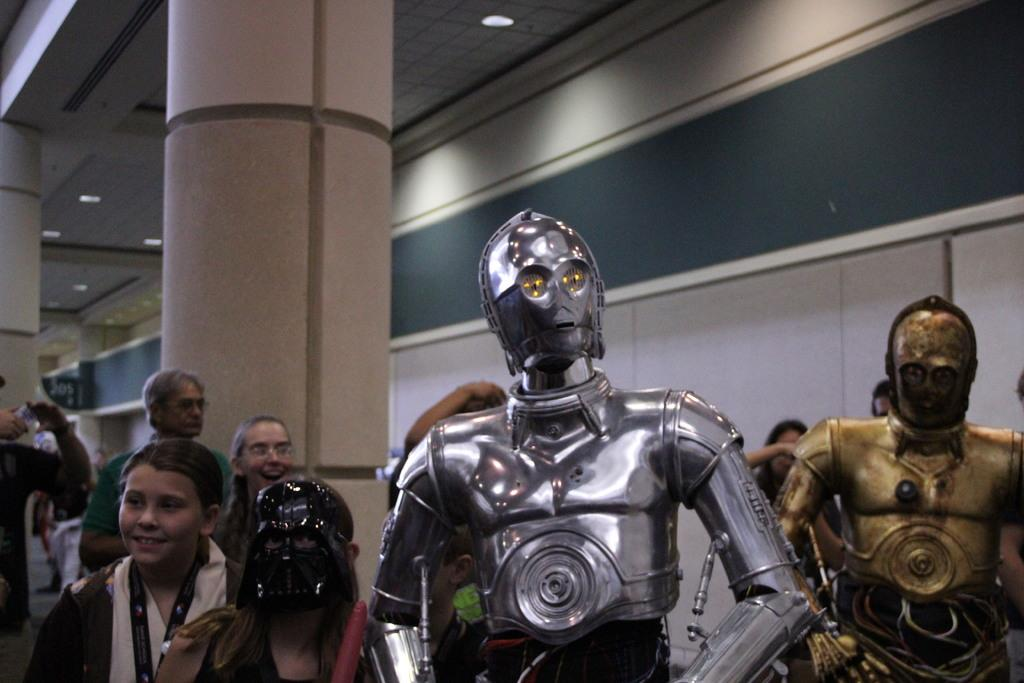What can be seen in the image besides people? There are two robots in the image. What is visible in the background of the image? There are many people in the background of the image. What type of lighting is present in the image? There are lights on the ceiling in the image. What architectural features can be seen in the image? There are pillars in the image. What type of kite is being flown by one of the robots in the image? There are no kites present in the image; it features two robots and many people in the background. What is the limit of the robots' abilities in the image? The provided facts do not mention any limits on the robots' abilities, so we cannot determine their capabilities from the image. 